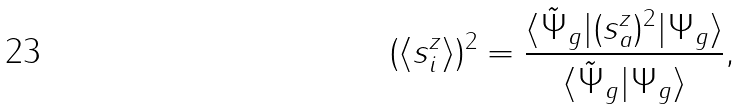Convert formula to latex. <formula><loc_0><loc_0><loc_500><loc_500>( \langle s ^ { z } _ { i } \rangle ) ^ { 2 } = \frac { \langle \tilde { \Psi } _ { g } | ( s ^ { z } _ { a } ) ^ { 2 } | \Psi _ { g } \rangle } { \langle \tilde { \Psi } _ { g } | \Psi _ { g } \rangle } ,</formula> 